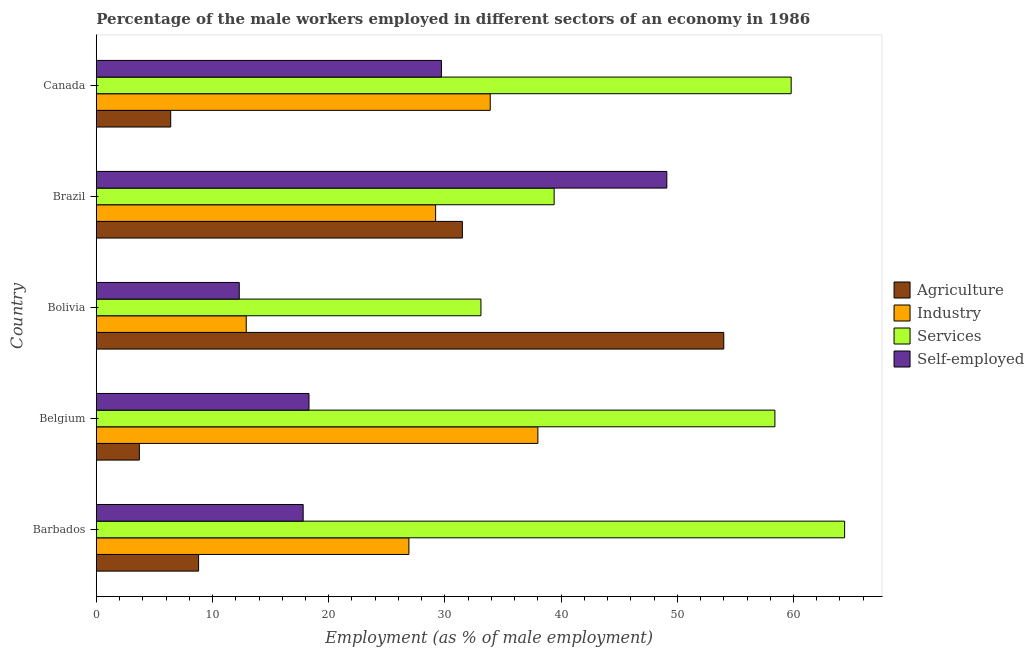How many different coloured bars are there?
Give a very brief answer. 4. How many groups of bars are there?
Your answer should be very brief. 5. Are the number of bars on each tick of the Y-axis equal?
Provide a short and direct response. Yes. How many bars are there on the 3rd tick from the bottom?
Provide a short and direct response. 4. What is the label of the 3rd group of bars from the top?
Offer a terse response. Bolivia. What is the percentage of male workers in services in Belgium?
Give a very brief answer. 58.4. Across all countries, what is the maximum percentage of self employed male workers?
Give a very brief answer. 49.1. Across all countries, what is the minimum percentage of male workers in services?
Your answer should be compact. 33.1. In which country was the percentage of male workers in services maximum?
Provide a short and direct response. Barbados. In which country was the percentage of male workers in industry minimum?
Offer a very short reply. Bolivia. What is the total percentage of male workers in agriculture in the graph?
Your response must be concise. 104.4. What is the difference between the percentage of self employed male workers in Belgium and that in Brazil?
Keep it short and to the point. -30.8. What is the difference between the percentage of self employed male workers in Bolivia and the percentage of male workers in agriculture in Belgium?
Your answer should be very brief. 8.6. What is the average percentage of self employed male workers per country?
Offer a terse response. 25.44. What is the difference between the percentage of male workers in agriculture and percentage of male workers in services in Belgium?
Your answer should be very brief. -54.7. In how many countries, is the percentage of male workers in services greater than 22 %?
Keep it short and to the point. 5. What is the ratio of the percentage of self employed male workers in Belgium to that in Bolivia?
Provide a short and direct response. 1.49. Is the difference between the percentage of male workers in agriculture in Belgium and Canada greater than the difference between the percentage of male workers in services in Belgium and Canada?
Keep it short and to the point. No. What is the difference between the highest and the lowest percentage of male workers in services?
Keep it short and to the point. 31.3. Is it the case that in every country, the sum of the percentage of male workers in services and percentage of male workers in agriculture is greater than the sum of percentage of male workers in industry and percentage of self employed male workers?
Your answer should be compact. No. What does the 2nd bar from the top in Brazil represents?
Provide a short and direct response. Services. What does the 4th bar from the bottom in Belgium represents?
Give a very brief answer. Self-employed. How many bars are there?
Keep it short and to the point. 20. How many countries are there in the graph?
Your answer should be compact. 5. How are the legend labels stacked?
Your answer should be very brief. Vertical. What is the title of the graph?
Provide a succinct answer. Percentage of the male workers employed in different sectors of an economy in 1986. Does "PFC gas" appear as one of the legend labels in the graph?
Offer a terse response. No. What is the label or title of the X-axis?
Provide a succinct answer. Employment (as % of male employment). What is the label or title of the Y-axis?
Give a very brief answer. Country. What is the Employment (as % of male employment) of Agriculture in Barbados?
Your answer should be compact. 8.8. What is the Employment (as % of male employment) in Industry in Barbados?
Provide a short and direct response. 26.9. What is the Employment (as % of male employment) in Services in Barbados?
Ensure brevity in your answer.  64.4. What is the Employment (as % of male employment) in Self-employed in Barbados?
Provide a succinct answer. 17.8. What is the Employment (as % of male employment) of Agriculture in Belgium?
Keep it short and to the point. 3.7. What is the Employment (as % of male employment) of Industry in Belgium?
Keep it short and to the point. 38. What is the Employment (as % of male employment) in Services in Belgium?
Keep it short and to the point. 58.4. What is the Employment (as % of male employment) in Self-employed in Belgium?
Your response must be concise. 18.3. What is the Employment (as % of male employment) in Industry in Bolivia?
Keep it short and to the point. 12.9. What is the Employment (as % of male employment) of Services in Bolivia?
Provide a succinct answer. 33.1. What is the Employment (as % of male employment) of Self-employed in Bolivia?
Ensure brevity in your answer.  12.3. What is the Employment (as % of male employment) of Agriculture in Brazil?
Provide a succinct answer. 31.5. What is the Employment (as % of male employment) in Industry in Brazil?
Offer a terse response. 29.2. What is the Employment (as % of male employment) in Services in Brazil?
Provide a succinct answer. 39.4. What is the Employment (as % of male employment) in Self-employed in Brazil?
Give a very brief answer. 49.1. What is the Employment (as % of male employment) in Agriculture in Canada?
Your response must be concise. 6.4. What is the Employment (as % of male employment) of Industry in Canada?
Provide a short and direct response. 33.9. What is the Employment (as % of male employment) in Services in Canada?
Make the answer very short. 59.8. What is the Employment (as % of male employment) of Self-employed in Canada?
Your answer should be very brief. 29.7. Across all countries, what is the maximum Employment (as % of male employment) in Agriculture?
Offer a very short reply. 54. Across all countries, what is the maximum Employment (as % of male employment) of Industry?
Ensure brevity in your answer.  38. Across all countries, what is the maximum Employment (as % of male employment) in Services?
Make the answer very short. 64.4. Across all countries, what is the maximum Employment (as % of male employment) of Self-employed?
Make the answer very short. 49.1. Across all countries, what is the minimum Employment (as % of male employment) of Agriculture?
Ensure brevity in your answer.  3.7. Across all countries, what is the minimum Employment (as % of male employment) of Industry?
Ensure brevity in your answer.  12.9. Across all countries, what is the minimum Employment (as % of male employment) of Services?
Your answer should be compact. 33.1. Across all countries, what is the minimum Employment (as % of male employment) in Self-employed?
Provide a succinct answer. 12.3. What is the total Employment (as % of male employment) of Agriculture in the graph?
Keep it short and to the point. 104.4. What is the total Employment (as % of male employment) in Industry in the graph?
Give a very brief answer. 140.9. What is the total Employment (as % of male employment) of Services in the graph?
Your response must be concise. 255.1. What is the total Employment (as % of male employment) in Self-employed in the graph?
Provide a succinct answer. 127.2. What is the difference between the Employment (as % of male employment) of Industry in Barbados and that in Belgium?
Provide a short and direct response. -11.1. What is the difference between the Employment (as % of male employment) in Self-employed in Barbados and that in Belgium?
Give a very brief answer. -0.5. What is the difference between the Employment (as % of male employment) of Agriculture in Barbados and that in Bolivia?
Give a very brief answer. -45.2. What is the difference between the Employment (as % of male employment) in Services in Barbados and that in Bolivia?
Make the answer very short. 31.3. What is the difference between the Employment (as % of male employment) of Agriculture in Barbados and that in Brazil?
Offer a terse response. -22.7. What is the difference between the Employment (as % of male employment) of Self-employed in Barbados and that in Brazil?
Offer a very short reply. -31.3. What is the difference between the Employment (as % of male employment) of Industry in Barbados and that in Canada?
Offer a terse response. -7. What is the difference between the Employment (as % of male employment) in Self-employed in Barbados and that in Canada?
Provide a short and direct response. -11.9. What is the difference between the Employment (as % of male employment) of Agriculture in Belgium and that in Bolivia?
Your response must be concise. -50.3. What is the difference between the Employment (as % of male employment) of Industry in Belgium and that in Bolivia?
Ensure brevity in your answer.  25.1. What is the difference between the Employment (as % of male employment) in Services in Belgium and that in Bolivia?
Make the answer very short. 25.3. What is the difference between the Employment (as % of male employment) in Agriculture in Belgium and that in Brazil?
Make the answer very short. -27.8. What is the difference between the Employment (as % of male employment) of Services in Belgium and that in Brazil?
Offer a terse response. 19. What is the difference between the Employment (as % of male employment) of Self-employed in Belgium and that in Brazil?
Ensure brevity in your answer.  -30.8. What is the difference between the Employment (as % of male employment) of Industry in Belgium and that in Canada?
Your answer should be very brief. 4.1. What is the difference between the Employment (as % of male employment) in Services in Belgium and that in Canada?
Your answer should be very brief. -1.4. What is the difference between the Employment (as % of male employment) in Agriculture in Bolivia and that in Brazil?
Ensure brevity in your answer.  22.5. What is the difference between the Employment (as % of male employment) in Industry in Bolivia and that in Brazil?
Offer a very short reply. -16.3. What is the difference between the Employment (as % of male employment) of Self-employed in Bolivia and that in Brazil?
Offer a very short reply. -36.8. What is the difference between the Employment (as % of male employment) of Agriculture in Bolivia and that in Canada?
Offer a very short reply. 47.6. What is the difference between the Employment (as % of male employment) in Industry in Bolivia and that in Canada?
Offer a terse response. -21. What is the difference between the Employment (as % of male employment) of Services in Bolivia and that in Canada?
Give a very brief answer. -26.7. What is the difference between the Employment (as % of male employment) of Self-employed in Bolivia and that in Canada?
Make the answer very short. -17.4. What is the difference between the Employment (as % of male employment) of Agriculture in Brazil and that in Canada?
Your answer should be very brief. 25.1. What is the difference between the Employment (as % of male employment) of Industry in Brazil and that in Canada?
Give a very brief answer. -4.7. What is the difference between the Employment (as % of male employment) of Services in Brazil and that in Canada?
Offer a very short reply. -20.4. What is the difference between the Employment (as % of male employment) in Agriculture in Barbados and the Employment (as % of male employment) in Industry in Belgium?
Your answer should be compact. -29.2. What is the difference between the Employment (as % of male employment) of Agriculture in Barbados and the Employment (as % of male employment) of Services in Belgium?
Provide a short and direct response. -49.6. What is the difference between the Employment (as % of male employment) of Industry in Barbados and the Employment (as % of male employment) of Services in Belgium?
Provide a succinct answer. -31.5. What is the difference between the Employment (as % of male employment) in Industry in Barbados and the Employment (as % of male employment) in Self-employed in Belgium?
Your response must be concise. 8.6. What is the difference between the Employment (as % of male employment) of Services in Barbados and the Employment (as % of male employment) of Self-employed in Belgium?
Give a very brief answer. 46.1. What is the difference between the Employment (as % of male employment) in Agriculture in Barbados and the Employment (as % of male employment) in Services in Bolivia?
Offer a very short reply. -24.3. What is the difference between the Employment (as % of male employment) in Agriculture in Barbados and the Employment (as % of male employment) in Self-employed in Bolivia?
Provide a succinct answer. -3.5. What is the difference between the Employment (as % of male employment) of Industry in Barbados and the Employment (as % of male employment) of Services in Bolivia?
Ensure brevity in your answer.  -6.2. What is the difference between the Employment (as % of male employment) of Services in Barbados and the Employment (as % of male employment) of Self-employed in Bolivia?
Your response must be concise. 52.1. What is the difference between the Employment (as % of male employment) in Agriculture in Barbados and the Employment (as % of male employment) in Industry in Brazil?
Your answer should be compact. -20.4. What is the difference between the Employment (as % of male employment) in Agriculture in Barbados and the Employment (as % of male employment) in Services in Brazil?
Offer a terse response. -30.6. What is the difference between the Employment (as % of male employment) of Agriculture in Barbados and the Employment (as % of male employment) of Self-employed in Brazil?
Offer a terse response. -40.3. What is the difference between the Employment (as % of male employment) in Industry in Barbados and the Employment (as % of male employment) in Services in Brazil?
Ensure brevity in your answer.  -12.5. What is the difference between the Employment (as % of male employment) in Industry in Barbados and the Employment (as % of male employment) in Self-employed in Brazil?
Your answer should be compact. -22.2. What is the difference between the Employment (as % of male employment) in Agriculture in Barbados and the Employment (as % of male employment) in Industry in Canada?
Keep it short and to the point. -25.1. What is the difference between the Employment (as % of male employment) of Agriculture in Barbados and the Employment (as % of male employment) of Services in Canada?
Your answer should be very brief. -51. What is the difference between the Employment (as % of male employment) of Agriculture in Barbados and the Employment (as % of male employment) of Self-employed in Canada?
Your answer should be very brief. -20.9. What is the difference between the Employment (as % of male employment) of Industry in Barbados and the Employment (as % of male employment) of Services in Canada?
Your answer should be very brief. -32.9. What is the difference between the Employment (as % of male employment) of Industry in Barbados and the Employment (as % of male employment) of Self-employed in Canada?
Your answer should be compact. -2.8. What is the difference between the Employment (as % of male employment) in Services in Barbados and the Employment (as % of male employment) in Self-employed in Canada?
Provide a short and direct response. 34.7. What is the difference between the Employment (as % of male employment) in Agriculture in Belgium and the Employment (as % of male employment) in Services in Bolivia?
Offer a very short reply. -29.4. What is the difference between the Employment (as % of male employment) in Agriculture in Belgium and the Employment (as % of male employment) in Self-employed in Bolivia?
Give a very brief answer. -8.6. What is the difference between the Employment (as % of male employment) of Industry in Belgium and the Employment (as % of male employment) of Services in Bolivia?
Offer a terse response. 4.9. What is the difference between the Employment (as % of male employment) in Industry in Belgium and the Employment (as % of male employment) in Self-employed in Bolivia?
Make the answer very short. 25.7. What is the difference between the Employment (as % of male employment) in Services in Belgium and the Employment (as % of male employment) in Self-employed in Bolivia?
Offer a very short reply. 46.1. What is the difference between the Employment (as % of male employment) in Agriculture in Belgium and the Employment (as % of male employment) in Industry in Brazil?
Your answer should be compact. -25.5. What is the difference between the Employment (as % of male employment) of Agriculture in Belgium and the Employment (as % of male employment) of Services in Brazil?
Make the answer very short. -35.7. What is the difference between the Employment (as % of male employment) in Agriculture in Belgium and the Employment (as % of male employment) in Self-employed in Brazil?
Your answer should be compact. -45.4. What is the difference between the Employment (as % of male employment) in Industry in Belgium and the Employment (as % of male employment) in Services in Brazil?
Offer a terse response. -1.4. What is the difference between the Employment (as % of male employment) of Services in Belgium and the Employment (as % of male employment) of Self-employed in Brazil?
Your answer should be compact. 9.3. What is the difference between the Employment (as % of male employment) in Agriculture in Belgium and the Employment (as % of male employment) in Industry in Canada?
Your answer should be very brief. -30.2. What is the difference between the Employment (as % of male employment) in Agriculture in Belgium and the Employment (as % of male employment) in Services in Canada?
Make the answer very short. -56.1. What is the difference between the Employment (as % of male employment) of Industry in Belgium and the Employment (as % of male employment) of Services in Canada?
Ensure brevity in your answer.  -21.8. What is the difference between the Employment (as % of male employment) of Services in Belgium and the Employment (as % of male employment) of Self-employed in Canada?
Give a very brief answer. 28.7. What is the difference between the Employment (as % of male employment) of Agriculture in Bolivia and the Employment (as % of male employment) of Industry in Brazil?
Your answer should be very brief. 24.8. What is the difference between the Employment (as % of male employment) in Agriculture in Bolivia and the Employment (as % of male employment) in Services in Brazil?
Offer a terse response. 14.6. What is the difference between the Employment (as % of male employment) of Industry in Bolivia and the Employment (as % of male employment) of Services in Brazil?
Provide a succinct answer. -26.5. What is the difference between the Employment (as % of male employment) in Industry in Bolivia and the Employment (as % of male employment) in Self-employed in Brazil?
Provide a short and direct response. -36.2. What is the difference between the Employment (as % of male employment) of Services in Bolivia and the Employment (as % of male employment) of Self-employed in Brazil?
Offer a very short reply. -16. What is the difference between the Employment (as % of male employment) of Agriculture in Bolivia and the Employment (as % of male employment) of Industry in Canada?
Offer a very short reply. 20.1. What is the difference between the Employment (as % of male employment) of Agriculture in Bolivia and the Employment (as % of male employment) of Self-employed in Canada?
Ensure brevity in your answer.  24.3. What is the difference between the Employment (as % of male employment) of Industry in Bolivia and the Employment (as % of male employment) of Services in Canada?
Make the answer very short. -46.9. What is the difference between the Employment (as % of male employment) in Industry in Bolivia and the Employment (as % of male employment) in Self-employed in Canada?
Give a very brief answer. -16.8. What is the difference between the Employment (as % of male employment) in Agriculture in Brazil and the Employment (as % of male employment) in Services in Canada?
Provide a succinct answer. -28.3. What is the difference between the Employment (as % of male employment) of Agriculture in Brazil and the Employment (as % of male employment) of Self-employed in Canada?
Provide a short and direct response. 1.8. What is the difference between the Employment (as % of male employment) in Industry in Brazil and the Employment (as % of male employment) in Services in Canada?
Offer a terse response. -30.6. What is the average Employment (as % of male employment) of Agriculture per country?
Offer a very short reply. 20.88. What is the average Employment (as % of male employment) of Industry per country?
Provide a short and direct response. 28.18. What is the average Employment (as % of male employment) of Services per country?
Offer a terse response. 51.02. What is the average Employment (as % of male employment) of Self-employed per country?
Your response must be concise. 25.44. What is the difference between the Employment (as % of male employment) in Agriculture and Employment (as % of male employment) in Industry in Barbados?
Offer a very short reply. -18.1. What is the difference between the Employment (as % of male employment) in Agriculture and Employment (as % of male employment) in Services in Barbados?
Your response must be concise. -55.6. What is the difference between the Employment (as % of male employment) in Agriculture and Employment (as % of male employment) in Self-employed in Barbados?
Your response must be concise. -9. What is the difference between the Employment (as % of male employment) of Industry and Employment (as % of male employment) of Services in Barbados?
Make the answer very short. -37.5. What is the difference between the Employment (as % of male employment) in Industry and Employment (as % of male employment) in Self-employed in Barbados?
Provide a succinct answer. 9.1. What is the difference between the Employment (as % of male employment) in Services and Employment (as % of male employment) in Self-employed in Barbados?
Your response must be concise. 46.6. What is the difference between the Employment (as % of male employment) in Agriculture and Employment (as % of male employment) in Industry in Belgium?
Ensure brevity in your answer.  -34.3. What is the difference between the Employment (as % of male employment) of Agriculture and Employment (as % of male employment) of Services in Belgium?
Offer a very short reply. -54.7. What is the difference between the Employment (as % of male employment) in Agriculture and Employment (as % of male employment) in Self-employed in Belgium?
Ensure brevity in your answer.  -14.6. What is the difference between the Employment (as % of male employment) of Industry and Employment (as % of male employment) of Services in Belgium?
Offer a very short reply. -20.4. What is the difference between the Employment (as % of male employment) of Industry and Employment (as % of male employment) of Self-employed in Belgium?
Provide a succinct answer. 19.7. What is the difference between the Employment (as % of male employment) of Services and Employment (as % of male employment) of Self-employed in Belgium?
Offer a very short reply. 40.1. What is the difference between the Employment (as % of male employment) in Agriculture and Employment (as % of male employment) in Industry in Bolivia?
Ensure brevity in your answer.  41.1. What is the difference between the Employment (as % of male employment) of Agriculture and Employment (as % of male employment) of Services in Bolivia?
Offer a very short reply. 20.9. What is the difference between the Employment (as % of male employment) of Agriculture and Employment (as % of male employment) of Self-employed in Bolivia?
Keep it short and to the point. 41.7. What is the difference between the Employment (as % of male employment) in Industry and Employment (as % of male employment) in Services in Bolivia?
Your answer should be very brief. -20.2. What is the difference between the Employment (as % of male employment) of Industry and Employment (as % of male employment) of Self-employed in Bolivia?
Your answer should be very brief. 0.6. What is the difference between the Employment (as % of male employment) in Services and Employment (as % of male employment) in Self-employed in Bolivia?
Provide a short and direct response. 20.8. What is the difference between the Employment (as % of male employment) of Agriculture and Employment (as % of male employment) of Self-employed in Brazil?
Make the answer very short. -17.6. What is the difference between the Employment (as % of male employment) of Industry and Employment (as % of male employment) of Self-employed in Brazil?
Your answer should be very brief. -19.9. What is the difference between the Employment (as % of male employment) of Agriculture and Employment (as % of male employment) of Industry in Canada?
Provide a succinct answer. -27.5. What is the difference between the Employment (as % of male employment) in Agriculture and Employment (as % of male employment) in Services in Canada?
Make the answer very short. -53.4. What is the difference between the Employment (as % of male employment) in Agriculture and Employment (as % of male employment) in Self-employed in Canada?
Give a very brief answer. -23.3. What is the difference between the Employment (as % of male employment) in Industry and Employment (as % of male employment) in Services in Canada?
Make the answer very short. -25.9. What is the difference between the Employment (as % of male employment) in Industry and Employment (as % of male employment) in Self-employed in Canada?
Provide a succinct answer. 4.2. What is the difference between the Employment (as % of male employment) in Services and Employment (as % of male employment) in Self-employed in Canada?
Your answer should be compact. 30.1. What is the ratio of the Employment (as % of male employment) of Agriculture in Barbados to that in Belgium?
Your answer should be very brief. 2.38. What is the ratio of the Employment (as % of male employment) in Industry in Barbados to that in Belgium?
Ensure brevity in your answer.  0.71. What is the ratio of the Employment (as % of male employment) in Services in Barbados to that in Belgium?
Give a very brief answer. 1.1. What is the ratio of the Employment (as % of male employment) of Self-employed in Barbados to that in Belgium?
Offer a very short reply. 0.97. What is the ratio of the Employment (as % of male employment) of Agriculture in Barbados to that in Bolivia?
Offer a very short reply. 0.16. What is the ratio of the Employment (as % of male employment) of Industry in Barbados to that in Bolivia?
Offer a terse response. 2.09. What is the ratio of the Employment (as % of male employment) in Services in Barbados to that in Bolivia?
Offer a terse response. 1.95. What is the ratio of the Employment (as % of male employment) of Self-employed in Barbados to that in Bolivia?
Your response must be concise. 1.45. What is the ratio of the Employment (as % of male employment) in Agriculture in Barbados to that in Brazil?
Offer a very short reply. 0.28. What is the ratio of the Employment (as % of male employment) in Industry in Barbados to that in Brazil?
Offer a very short reply. 0.92. What is the ratio of the Employment (as % of male employment) in Services in Barbados to that in Brazil?
Give a very brief answer. 1.63. What is the ratio of the Employment (as % of male employment) of Self-employed in Barbados to that in Brazil?
Offer a very short reply. 0.36. What is the ratio of the Employment (as % of male employment) in Agriculture in Barbados to that in Canada?
Give a very brief answer. 1.38. What is the ratio of the Employment (as % of male employment) of Industry in Barbados to that in Canada?
Provide a succinct answer. 0.79. What is the ratio of the Employment (as % of male employment) of Self-employed in Barbados to that in Canada?
Your response must be concise. 0.6. What is the ratio of the Employment (as % of male employment) of Agriculture in Belgium to that in Bolivia?
Your response must be concise. 0.07. What is the ratio of the Employment (as % of male employment) of Industry in Belgium to that in Bolivia?
Your answer should be very brief. 2.95. What is the ratio of the Employment (as % of male employment) of Services in Belgium to that in Bolivia?
Keep it short and to the point. 1.76. What is the ratio of the Employment (as % of male employment) in Self-employed in Belgium to that in Bolivia?
Your answer should be compact. 1.49. What is the ratio of the Employment (as % of male employment) of Agriculture in Belgium to that in Brazil?
Keep it short and to the point. 0.12. What is the ratio of the Employment (as % of male employment) in Industry in Belgium to that in Brazil?
Provide a succinct answer. 1.3. What is the ratio of the Employment (as % of male employment) of Services in Belgium to that in Brazil?
Give a very brief answer. 1.48. What is the ratio of the Employment (as % of male employment) in Self-employed in Belgium to that in Brazil?
Ensure brevity in your answer.  0.37. What is the ratio of the Employment (as % of male employment) of Agriculture in Belgium to that in Canada?
Provide a succinct answer. 0.58. What is the ratio of the Employment (as % of male employment) of Industry in Belgium to that in Canada?
Your response must be concise. 1.12. What is the ratio of the Employment (as % of male employment) of Services in Belgium to that in Canada?
Offer a very short reply. 0.98. What is the ratio of the Employment (as % of male employment) of Self-employed in Belgium to that in Canada?
Give a very brief answer. 0.62. What is the ratio of the Employment (as % of male employment) in Agriculture in Bolivia to that in Brazil?
Keep it short and to the point. 1.71. What is the ratio of the Employment (as % of male employment) of Industry in Bolivia to that in Brazil?
Your answer should be compact. 0.44. What is the ratio of the Employment (as % of male employment) in Services in Bolivia to that in Brazil?
Provide a short and direct response. 0.84. What is the ratio of the Employment (as % of male employment) of Self-employed in Bolivia to that in Brazil?
Provide a succinct answer. 0.25. What is the ratio of the Employment (as % of male employment) of Agriculture in Bolivia to that in Canada?
Give a very brief answer. 8.44. What is the ratio of the Employment (as % of male employment) of Industry in Bolivia to that in Canada?
Offer a terse response. 0.38. What is the ratio of the Employment (as % of male employment) in Services in Bolivia to that in Canada?
Your response must be concise. 0.55. What is the ratio of the Employment (as % of male employment) in Self-employed in Bolivia to that in Canada?
Make the answer very short. 0.41. What is the ratio of the Employment (as % of male employment) in Agriculture in Brazil to that in Canada?
Ensure brevity in your answer.  4.92. What is the ratio of the Employment (as % of male employment) of Industry in Brazil to that in Canada?
Provide a succinct answer. 0.86. What is the ratio of the Employment (as % of male employment) in Services in Brazil to that in Canada?
Keep it short and to the point. 0.66. What is the ratio of the Employment (as % of male employment) in Self-employed in Brazil to that in Canada?
Your answer should be very brief. 1.65. What is the difference between the highest and the second highest Employment (as % of male employment) of Self-employed?
Give a very brief answer. 19.4. What is the difference between the highest and the lowest Employment (as % of male employment) in Agriculture?
Make the answer very short. 50.3. What is the difference between the highest and the lowest Employment (as % of male employment) in Industry?
Keep it short and to the point. 25.1. What is the difference between the highest and the lowest Employment (as % of male employment) in Services?
Your answer should be very brief. 31.3. What is the difference between the highest and the lowest Employment (as % of male employment) of Self-employed?
Your answer should be compact. 36.8. 